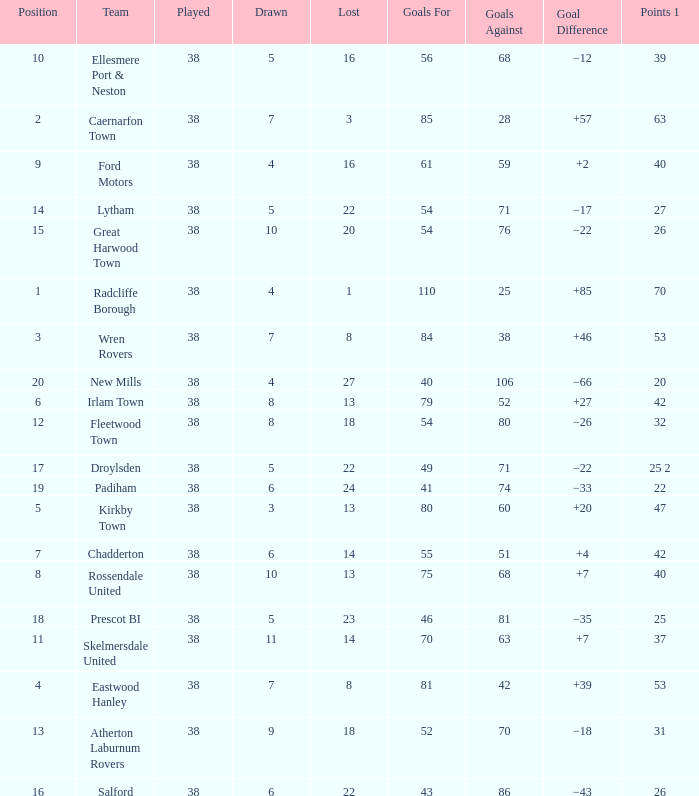Parse the table in full. {'header': ['Position', 'Team', 'Played', 'Drawn', 'Lost', 'Goals For', 'Goals Against', 'Goal Difference', 'Points 1'], 'rows': [['10', 'Ellesmere Port & Neston', '38', '5', '16', '56', '68', '−12', '39'], ['2', 'Caernarfon Town', '38', '7', '3', '85', '28', '+57', '63'], ['9', 'Ford Motors', '38', '4', '16', '61', '59', '+2', '40'], ['14', 'Lytham', '38', '5', '22', '54', '71', '−17', '27'], ['15', 'Great Harwood Town', '38', '10', '20', '54', '76', '−22', '26'], ['1', 'Radcliffe Borough', '38', '4', '1', '110', '25', '+85', '70'], ['3', 'Wren Rovers', '38', '7', '8', '84', '38', '+46', '53'], ['20', 'New Mills', '38', '4', '27', '40', '106', '−66', '20'], ['6', 'Irlam Town', '38', '8', '13', '79', '52', '+27', '42'], ['12', 'Fleetwood Town', '38', '8', '18', '54', '80', '−26', '32'], ['17', 'Droylsden', '38', '5', '22', '49', '71', '−22', '25 2'], ['19', 'Padiham', '38', '6', '24', '41', '74', '−33', '22'], ['5', 'Kirkby Town', '38', '3', '13', '80', '60', '+20', '47'], ['7', 'Chadderton', '38', '6', '14', '55', '51', '+4', '42'], ['8', 'Rossendale United', '38', '10', '13', '75', '68', '+7', '40'], ['18', 'Prescot BI', '38', '5', '23', '46', '81', '−35', '25'], ['11', 'Skelmersdale United', '38', '11', '14', '70', '63', '+7', '37'], ['4', 'Eastwood Hanley', '38', '7', '8', '81', '42', '+39', '53'], ['13', 'Atherton Laburnum Rovers', '38', '9', '18', '52', '70', '−18', '31'], ['16', 'Salford', '38', '6', '22', '43', '86', '−43', '26']]} Which Played has a Drawn of 4, and a Position of 9, and Goals Against larger than 59? None. 